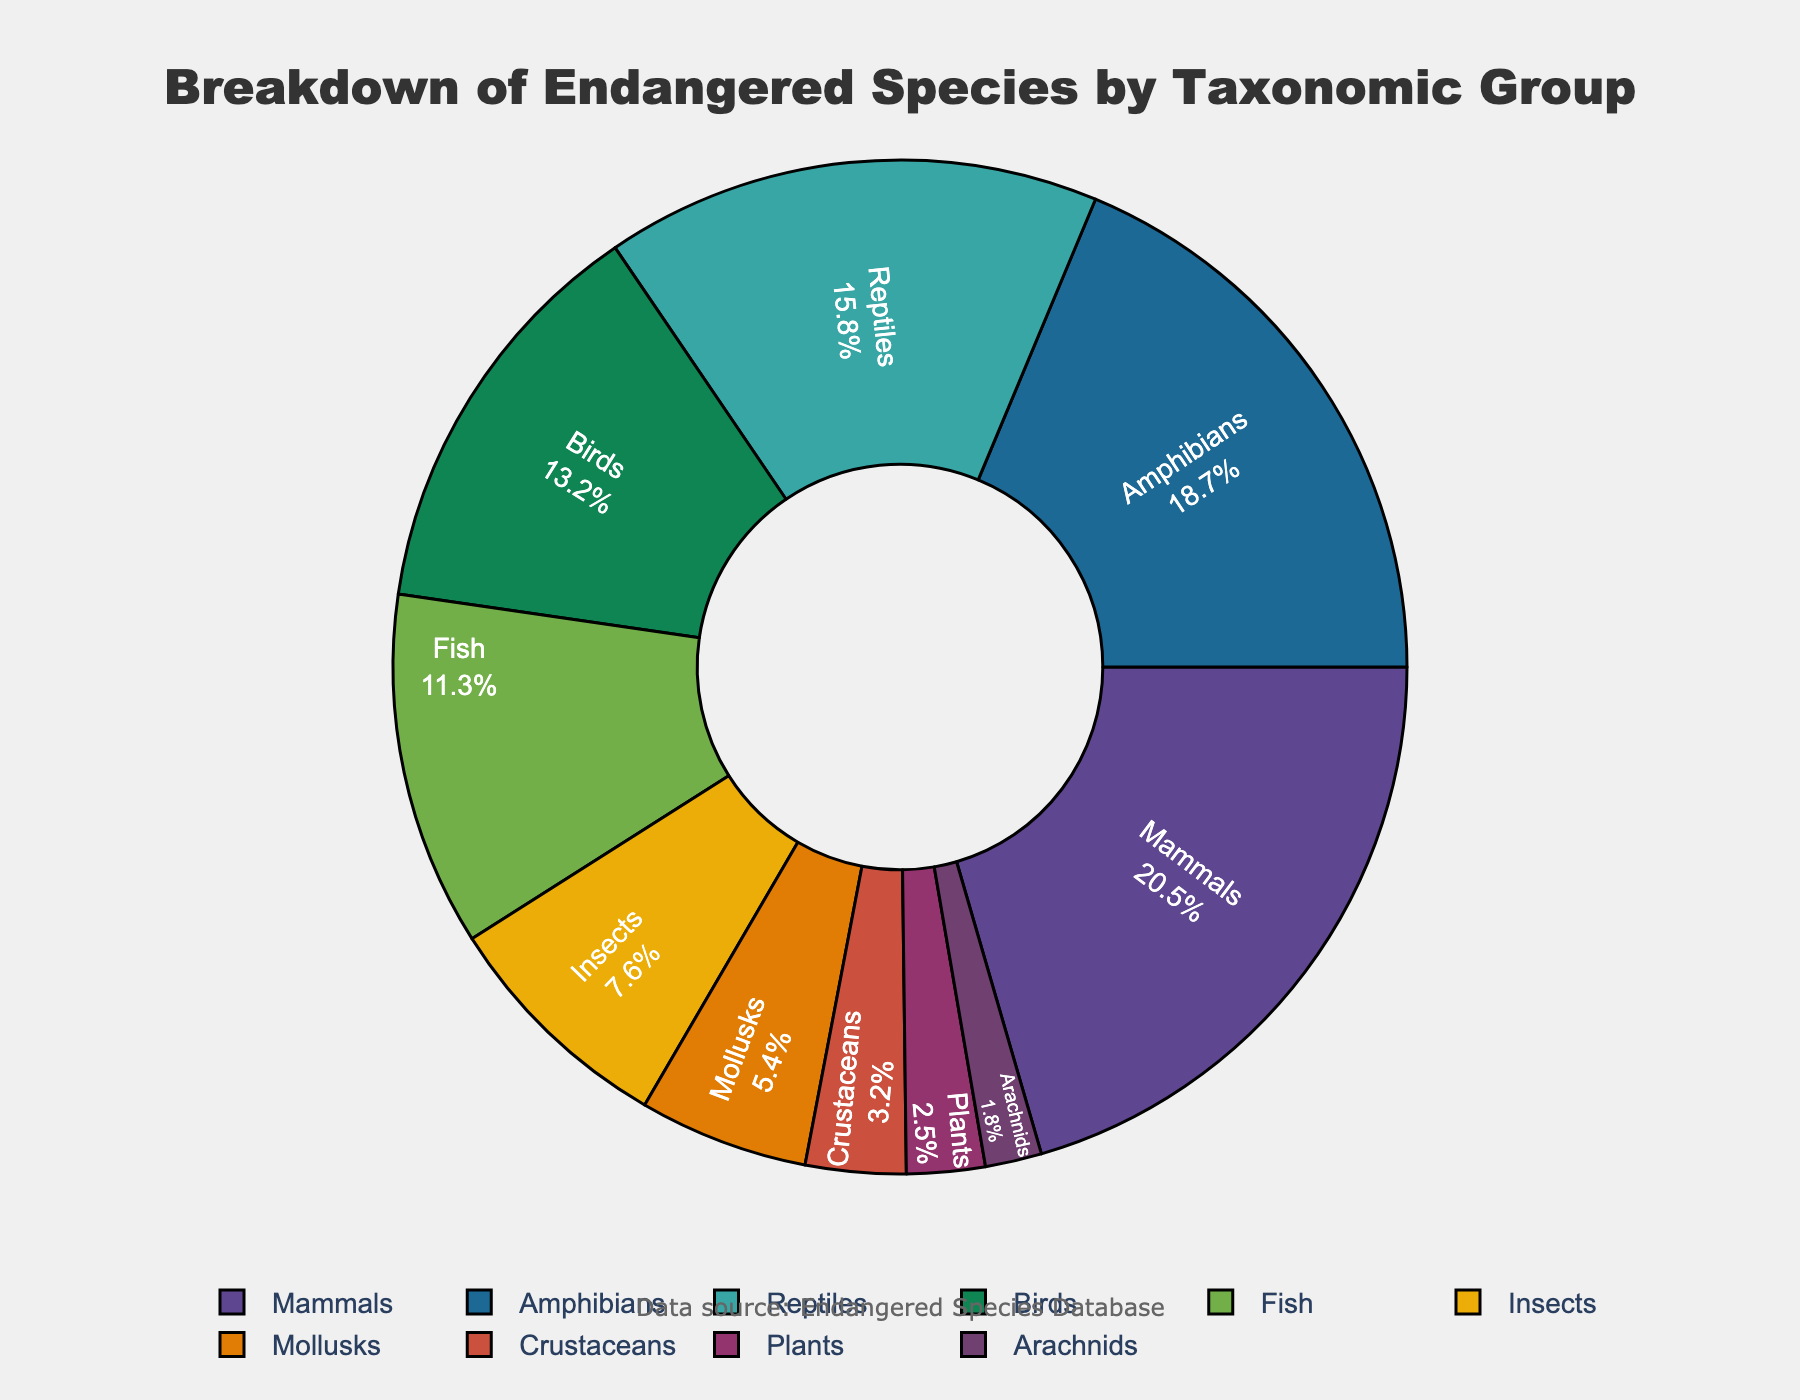What is the taxonomic group with the highest percentage of endangered species? The taxonomic group with the highest percentage will be represented by the largest slice of the pie chart. By examining the pie chart, we can identify the group.
Answer: Mammals Which taxonomic group has a lower percentage of endangered species: reptiles or amphibians? To determine this, we compare the sizes of the slices representing reptiles and amphibians. The label and percentage inside the pie chart can help us identify the comparison result.
Answer: Reptiles What is the combined percentage of endangered species for mammals and birds? Sum the percentages of these two groups by adding the values displayed on the pie chart (20.5% for mammals and 13.2% for birds).
Answer: 33.7% Which group has a larger percentage: insects or mollusks, and by how much? Compare the percentages of insects and mollusks by looking at the data points (7.6% for insects and 5.4% for mollusks). Subtract the smaller percentage from the larger one.
Answer: Insects by 2.2% Which three taxonomic groups have the smallest percentages of endangered species? Identify the three smallest slices in the pie chart. The labels and percentages will guide us in determining these groups.
Answer: Arachnids, Crustaceans, and Plants What percentage of endangered species is accounted for by fish if it is more than crustaceans but less than amphibians? Verify the percentage for fish displayed on the chart and confirm that it is between crustaceans' and amphibians' percentages (fish: 11.3%, crustaceans: 3.2%, amphibians: 18.7%).
Answer: 11.3% If you sum up the percentages of fish, insects, and mollusks, what would the total be? Add up the percentages displayed for each of these groups on the chart (fish: 11.3%, insects: 7.6%, mollusks: 5.4%).
Answer: 24.3% Does the combined percentage of mammals and amphibians exceed 35%? Add the percentages of mammals (20.5%) and amphibians (18.7%) from the chart and compare the result to 35%.
Answer: Yes, 39.2% Which group has a higher percentage of endangered species: birds or all aquatic organisms combined (fish, mollusks, and crustaceans)? Add the percentages for fish, mollusks, and crustaceans (11.3% + 5.4% + 3.2%) and compare the sum to the percentage for birds (13.2%).
Answer: Birds What is the difference in percentage between the two groups: insects and plants? Subtract the percentage of plants (2.5%) from the percentage of insects (7.6%) to find the difference.
Answer: 5.1% 